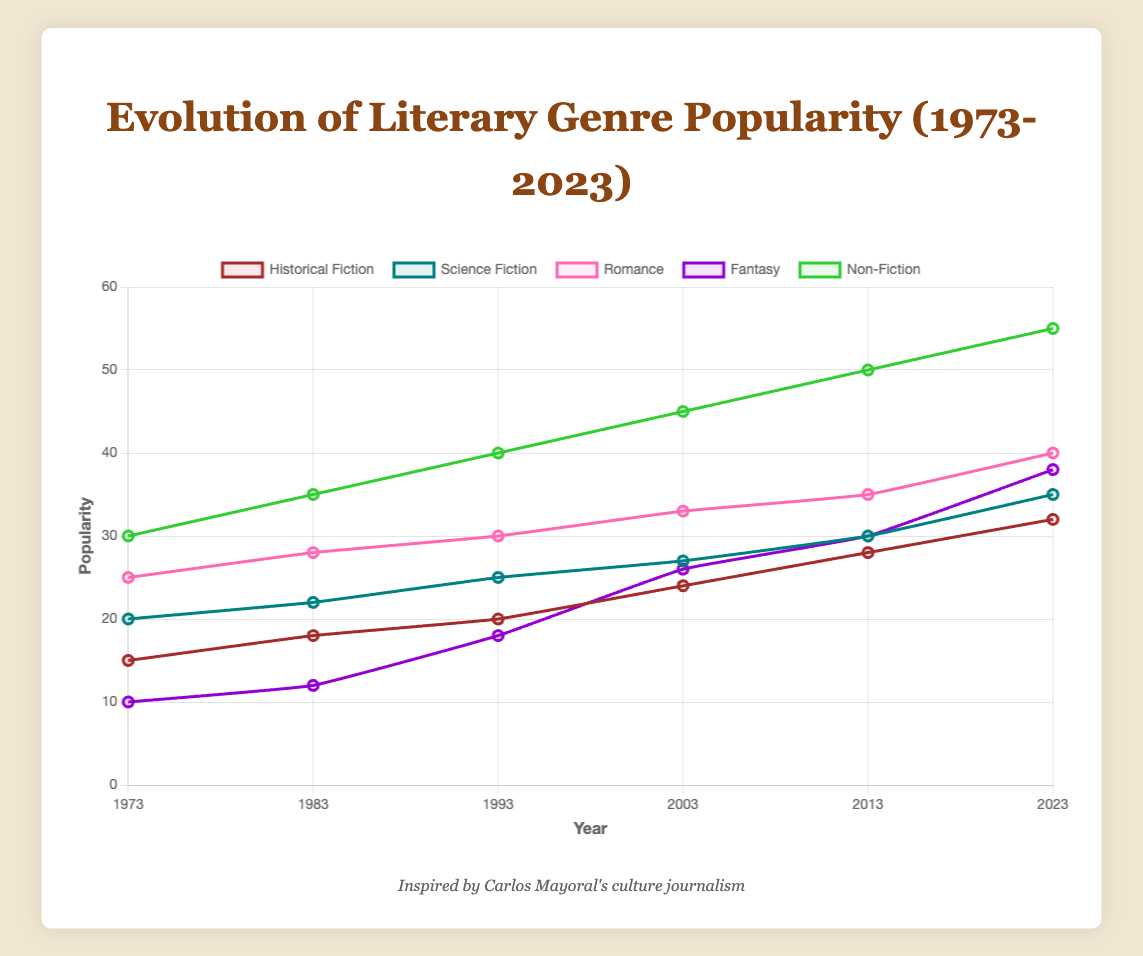Which genre had the highest increase in popularity from 1973 to 2023? To find the genre with the highest increase, we subtract the 1973 value from the 2023 value for each genre. The increases are: Historical Fiction: 32 - 15 = 17, Science Fiction: 35 - 20 = 15, Romance: 40 - 25 = 15, Fantasy: 38 - 10 = 28, Non-Fiction: 55 - 30 = 25. Fantasy had the highest increase of 28.
Answer: Fantasy In what year did Fantasy equal the popularity of Historical Fiction for the first time? We look for the first year in which both genres have the same popularity. In 2013, Fantasy and Historical Fiction both had a popularity of 30.
Answer: 2013 How much more popular was Romance compared to Historical Fiction in 2023? To find the difference, subtract the popularity of Historical Fiction from that of Romance in 2023: 40 - 32 = 8.
Answer: 8 What is the average popularity of Non-Fiction over the years presented? The popularity of Non-Fiction across the years is: 30, 35, 40, 45, 50, 55. The average is (30 + 35 + 40 + 45 + 50 + 55) / 6 = 255 / 6 = 42.5.
Answer: 42.5 Which genre had the smallest change in popularity from 1973 to 1983? To find the smallest change, subtract the values of 1973 from 1983 for each genre: Historical Fiction: 18 - 15 = 3, Science Fiction: 22 - 20 = 2, Romance: 28 - 25 = 3, Fantasy: 12 - 10 = 2, Non-Fiction: 35 - 30 = 5. The smallest change is 2 for both Science Fiction and Fantasy.
Answer: Science Fiction or Fantasy From 2003 to 2023, which genre saw the most significant rise in popularity? Subtract the values of 2003 from 2023 for each genre: Historical Fiction: 32 - 24 = 8, Science Fiction: 35 - 27 = 8, Romance: 40 - 33 = 7, Fantasy: 38 - 26 = 12, Non-Fiction: 55 - 45 = 10. Fantasy saw the most significant rise of 12.
Answer: Fantasy In what year did Science Fiction surpass the popularity of Non-Fiction? Compare the values for Science Fiction and Non-Fiction each year to find when Science Fiction became more popular. It never surpassed Non-Fiction within the given years.
Answer: Never What is the sum of the popularity of all genres in 2023? Summing the popularity values of all genres in 2023: 32 + 35 + 40 + 38 + 55 = 200.
Answer: 200 